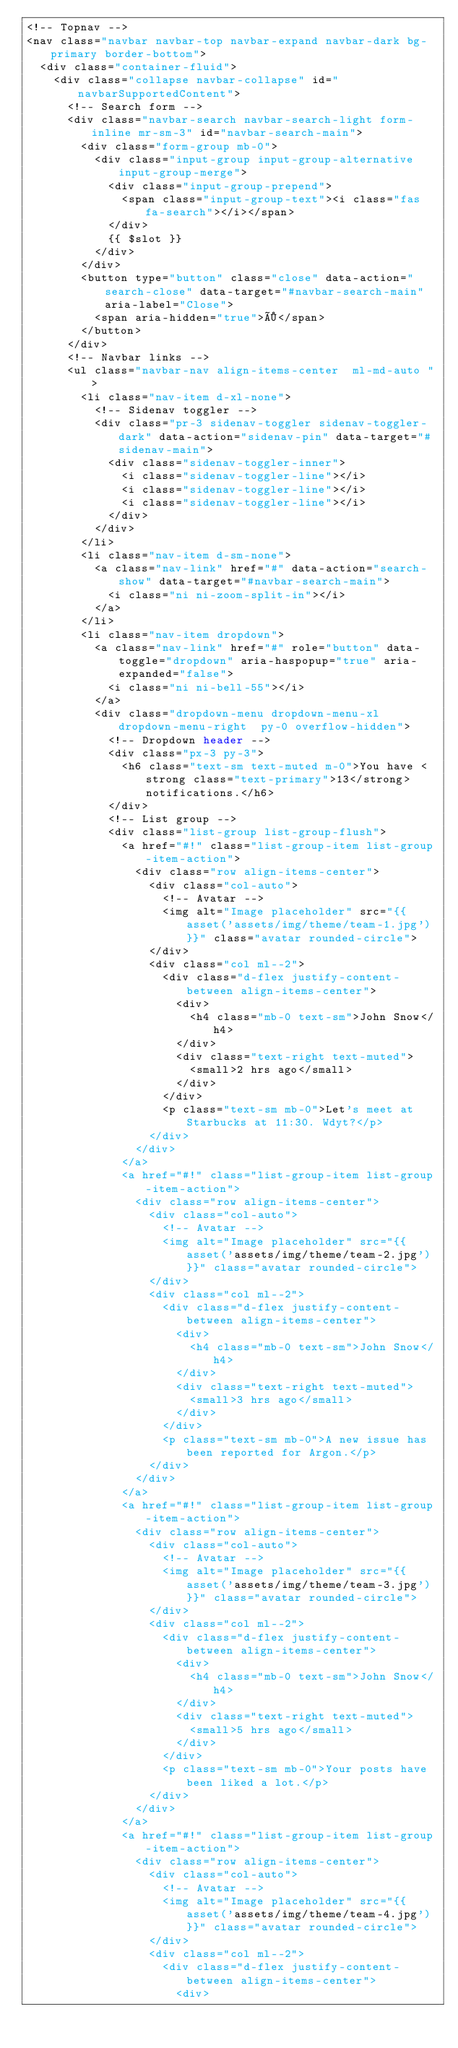<code> <loc_0><loc_0><loc_500><loc_500><_PHP_><!-- Topnav -->
<nav class="navbar navbar-top navbar-expand navbar-dark bg-primary border-bottom">
  <div class="container-fluid">
    <div class="collapse navbar-collapse" id="navbarSupportedContent">
      <!-- Search form -->
      <div class="navbar-search navbar-search-light form-inline mr-sm-3" id="navbar-search-main">
        <div class="form-group mb-0">
          <div class="input-group input-group-alternative input-group-merge">
            <div class="input-group-prepend">
              <span class="input-group-text"><i class="fas fa-search"></i></span>
            </div>
            {{ $slot }}
          </div>
        </div>
        <button type="button" class="close" data-action="search-close" data-target="#navbar-search-main" aria-label="Close">
          <span aria-hidden="true">×</span>
        </button>
      </div>
      <!-- Navbar links -->
      <ul class="navbar-nav align-items-center  ml-md-auto ">
        <li class="nav-item d-xl-none">
          <!-- Sidenav toggler -->
          <div class="pr-3 sidenav-toggler sidenav-toggler-dark" data-action="sidenav-pin" data-target="#sidenav-main">
            <div class="sidenav-toggler-inner">
              <i class="sidenav-toggler-line"></i>
              <i class="sidenav-toggler-line"></i>
              <i class="sidenav-toggler-line"></i>
            </div>
          </div>
        </li>
        <li class="nav-item d-sm-none">
          <a class="nav-link" href="#" data-action="search-show" data-target="#navbar-search-main">
            <i class="ni ni-zoom-split-in"></i>
          </a>
        </li>
        <li class="nav-item dropdown">
          <a class="nav-link" href="#" role="button" data-toggle="dropdown" aria-haspopup="true" aria-expanded="false">
            <i class="ni ni-bell-55"></i>
          </a>
          <div class="dropdown-menu dropdown-menu-xl  dropdown-menu-right  py-0 overflow-hidden">
            <!-- Dropdown header -->
            <div class="px-3 py-3">
              <h6 class="text-sm text-muted m-0">You have <strong class="text-primary">13</strong> notifications.</h6>
            </div>
            <!-- List group -->
            <div class="list-group list-group-flush">
              <a href="#!" class="list-group-item list-group-item-action">
                <div class="row align-items-center">
                  <div class="col-auto">
                    <!-- Avatar -->
                    <img alt="Image placeholder" src="{{ asset('assets/img/theme/team-1.jpg') }}" class="avatar rounded-circle">
                  </div>
                  <div class="col ml--2">
                    <div class="d-flex justify-content-between align-items-center">
                      <div>
                        <h4 class="mb-0 text-sm">John Snow</h4>
                      </div>
                      <div class="text-right text-muted">
                        <small>2 hrs ago</small>
                      </div>
                    </div>
                    <p class="text-sm mb-0">Let's meet at Starbucks at 11:30. Wdyt?</p>
                  </div>
                </div>
              </a>
              <a href="#!" class="list-group-item list-group-item-action">
                <div class="row align-items-center">
                  <div class="col-auto">
                    <!-- Avatar -->
                    <img alt="Image placeholder" src="{{ asset('assets/img/theme/team-2.jpg') }}" class="avatar rounded-circle">
                  </div>
                  <div class="col ml--2">
                    <div class="d-flex justify-content-between align-items-center">
                      <div>
                        <h4 class="mb-0 text-sm">John Snow</h4>
                      </div>
                      <div class="text-right text-muted">
                        <small>3 hrs ago</small>
                      </div>
                    </div>
                    <p class="text-sm mb-0">A new issue has been reported for Argon.</p>
                  </div>
                </div>
              </a>
              <a href="#!" class="list-group-item list-group-item-action">
                <div class="row align-items-center">
                  <div class="col-auto">
                    <!-- Avatar -->
                    <img alt="Image placeholder" src="{{ asset('assets/img/theme/team-3.jpg') }}" class="avatar rounded-circle">
                  </div>
                  <div class="col ml--2">
                    <div class="d-flex justify-content-between align-items-center">
                      <div>
                        <h4 class="mb-0 text-sm">John Snow</h4>
                      </div>
                      <div class="text-right text-muted">
                        <small>5 hrs ago</small>
                      </div>
                    </div>
                    <p class="text-sm mb-0">Your posts have been liked a lot.</p>
                  </div>
                </div>
              </a>
              <a href="#!" class="list-group-item list-group-item-action">
                <div class="row align-items-center">
                  <div class="col-auto">
                    <!-- Avatar -->
                    <img alt="Image placeholder" src="{{ asset('assets/img/theme/team-4.jpg') }}" class="avatar rounded-circle">
                  </div>
                  <div class="col ml--2">
                    <div class="d-flex justify-content-between align-items-center">
                      <div></code> 